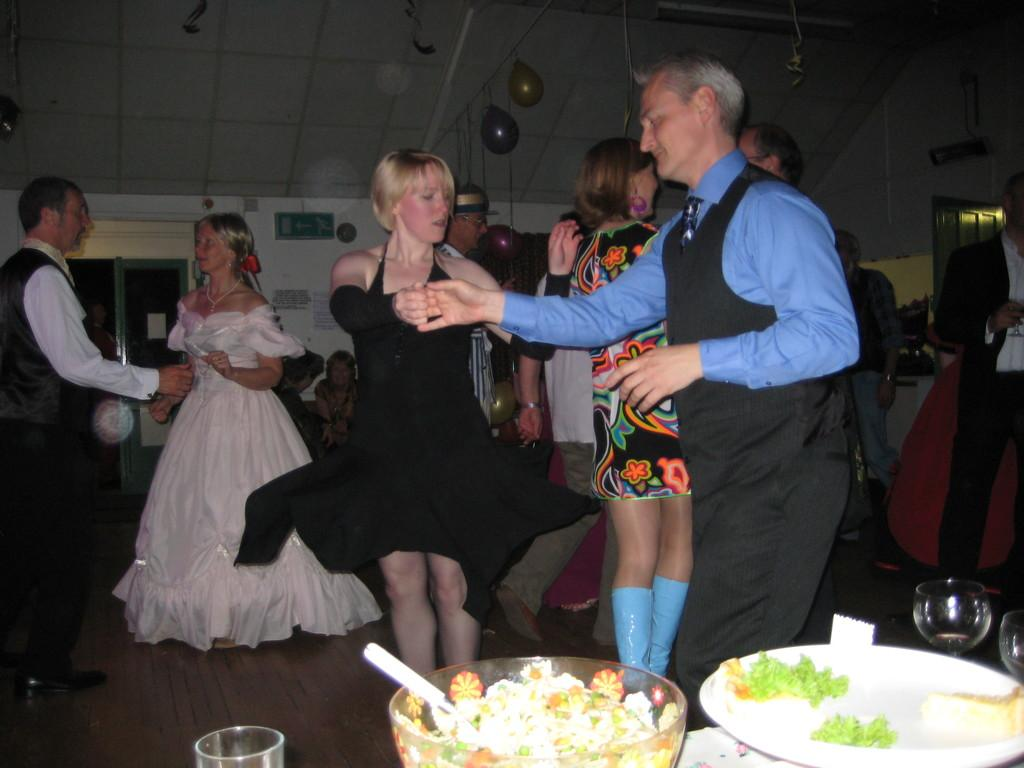How many people are in the image? There are people in the image, but the exact number is not specified. What can be seen in the image besides the people? There is at least one balloon, a signboard, doors, a plate, a bowl, glasses, food, and posters in the image. Where are the posters located in the image? The posters are on a wall in the image. What type of beef is being served on the plate in the image? There is no beef present in the image; the food shown cannot be identified as beef. 